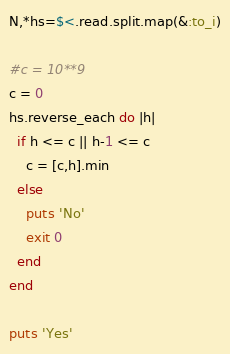<code> <loc_0><loc_0><loc_500><loc_500><_Ruby_>N,*hs=$<.read.split.map(&:to_i)

#c = 10**9
c = 0
hs.reverse_each do |h|
  if h <= c || h-1 <= c
    c = [c,h].min
  else
    puts 'No'
    exit 0
  end
end

puts 'Yes'
</code> 